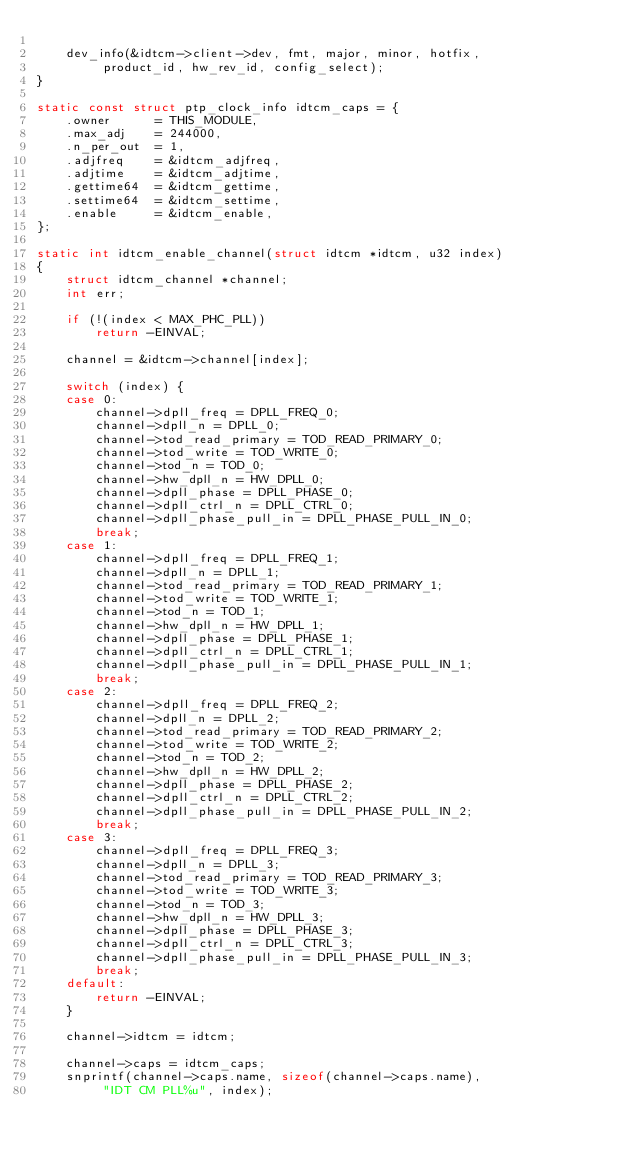<code> <loc_0><loc_0><loc_500><loc_500><_C_>
	dev_info(&idtcm->client->dev, fmt, major, minor, hotfix,
		 product_id, hw_rev_id, config_select);
}

static const struct ptp_clock_info idtcm_caps = {
	.owner		= THIS_MODULE,
	.max_adj	= 244000,
	.n_per_out	= 1,
	.adjfreq	= &idtcm_adjfreq,
	.adjtime	= &idtcm_adjtime,
	.gettime64	= &idtcm_gettime,
	.settime64	= &idtcm_settime,
	.enable		= &idtcm_enable,
};

static int idtcm_enable_channel(struct idtcm *idtcm, u32 index)
{
	struct idtcm_channel *channel;
	int err;

	if (!(index < MAX_PHC_PLL))
		return -EINVAL;

	channel = &idtcm->channel[index];

	switch (index) {
	case 0:
		channel->dpll_freq = DPLL_FREQ_0;
		channel->dpll_n = DPLL_0;
		channel->tod_read_primary = TOD_READ_PRIMARY_0;
		channel->tod_write = TOD_WRITE_0;
		channel->tod_n = TOD_0;
		channel->hw_dpll_n = HW_DPLL_0;
		channel->dpll_phase = DPLL_PHASE_0;
		channel->dpll_ctrl_n = DPLL_CTRL_0;
		channel->dpll_phase_pull_in = DPLL_PHASE_PULL_IN_0;
		break;
	case 1:
		channel->dpll_freq = DPLL_FREQ_1;
		channel->dpll_n = DPLL_1;
		channel->tod_read_primary = TOD_READ_PRIMARY_1;
		channel->tod_write = TOD_WRITE_1;
		channel->tod_n = TOD_1;
		channel->hw_dpll_n = HW_DPLL_1;
		channel->dpll_phase = DPLL_PHASE_1;
		channel->dpll_ctrl_n = DPLL_CTRL_1;
		channel->dpll_phase_pull_in = DPLL_PHASE_PULL_IN_1;
		break;
	case 2:
		channel->dpll_freq = DPLL_FREQ_2;
		channel->dpll_n = DPLL_2;
		channel->tod_read_primary = TOD_READ_PRIMARY_2;
		channel->tod_write = TOD_WRITE_2;
		channel->tod_n = TOD_2;
		channel->hw_dpll_n = HW_DPLL_2;
		channel->dpll_phase = DPLL_PHASE_2;
		channel->dpll_ctrl_n = DPLL_CTRL_2;
		channel->dpll_phase_pull_in = DPLL_PHASE_PULL_IN_2;
		break;
	case 3:
		channel->dpll_freq = DPLL_FREQ_3;
		channel->dpll_n = DPLL_3;
		channel->tod_read_primary = TOD_READ_PRIMARY_3;
		channel->tod_write = TOD_WRITE_3;
		channel->tod_n = TOD_3;
		channel->hw_dpll_n = HW_DPLL_3;
		channel->dpll_phase = DPLL_PHASE_3;
		channel->dpll_ctrl_n = DPLL_CTRL_3;
		channel->dpll_phase_pull_in = DPLL_PHASE_PULL_IN_3;
		break;
	default:
		return -EINVAL;
	}

	channel->idtcm = idtcm;

	channel->caps = idtcm_caps;
	snprintf(channel->caps.name, sizeof(channel->caps.name),
		 "IDT CM PLL%u", index);
</code> 